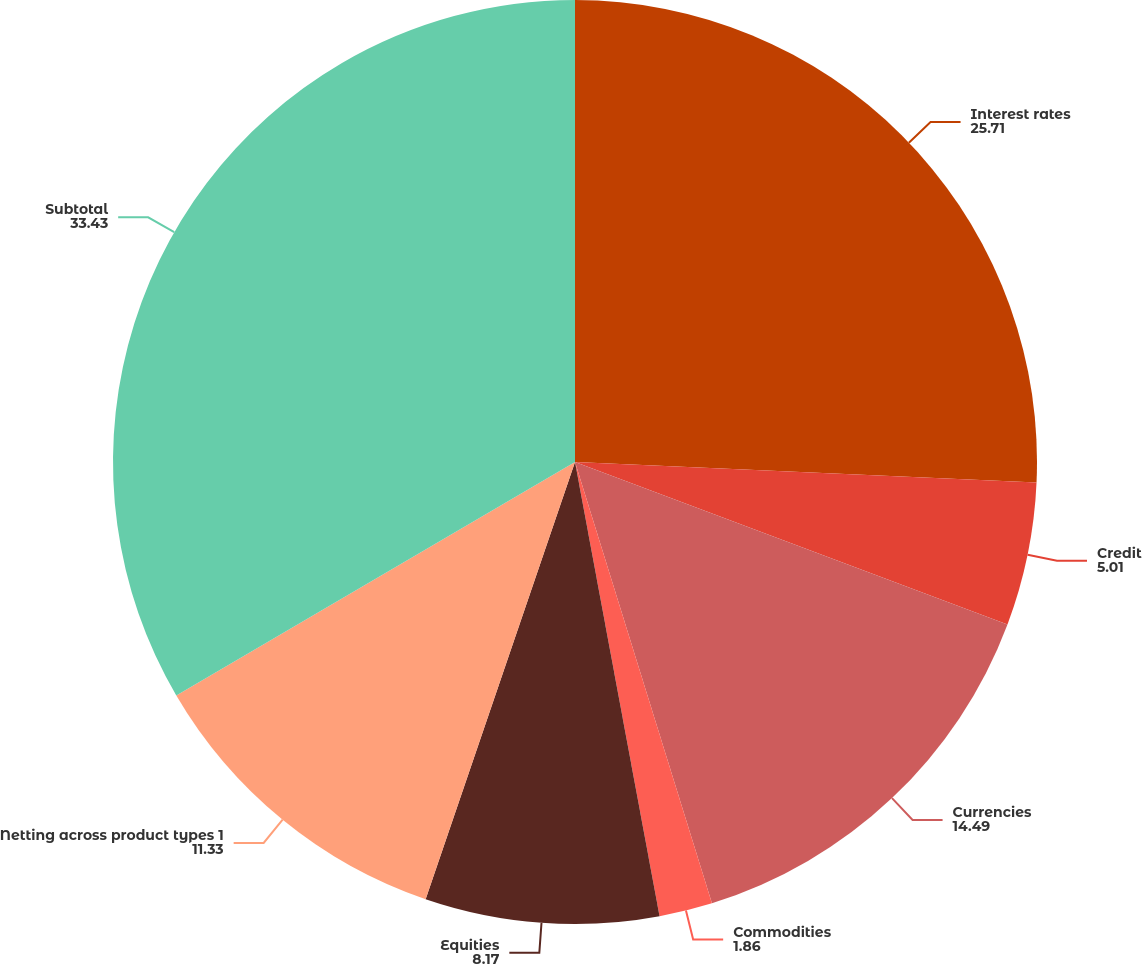Convert chart. <chart><loc_0><loc_0><loc_500><loc_500><pie_chart><fcel>Interest rates<fcel>Credit<fcel>Currencies<fcel>Commodities<fcel>Equities<fcel>Netting across product types 1<fcel>Subtotal<nl><fcel>25.71%<fcel>5.01%<fcel>14.49%<fcel>1.86%<fcel>8.17%<fcel>11.33%<fcel>33.43%<nl></chart> 